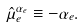Convert formula to latex. <formula><loc_0><loc_0><loc_500><loc_500>\hat { \mu } _ { e } ^ { \alpha _ { e } } \equiv - \alpha _ { e } .</formula> 